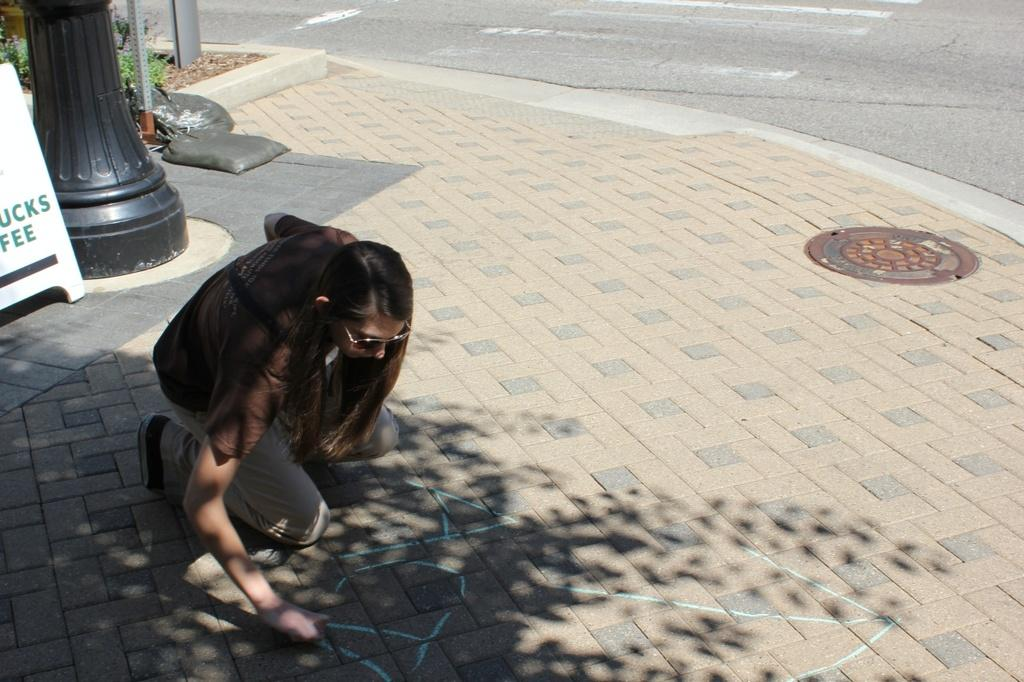What is the woman in the image doing? The woman is sitting and writing in the image. What else can be seen in the image besides the woman? There is a banner, a pole, plants, and black color bags in the image. What type of reward is the snail receiving from the giants in the image? There is no snail or giants present in the image, so it is not possible to answer that question. 